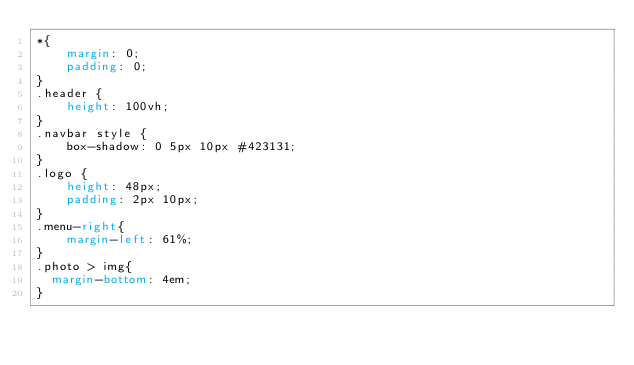<code> <loc_0><loc_0><loc_500><loc_500><_CSS_>*{
    margin: 0;
    padding: 0;
}
.header {
    height: 100vh;
}
.navbar style {
    box-shadow: 0 5px 10px #423131;
}
.logo {
    height: 48px;
    padding: 2px 10px;
}
.menu-right{
    margin-left: 61%;
}
.photo > img{
  margin-bottom: 4em;
}









































</code> 